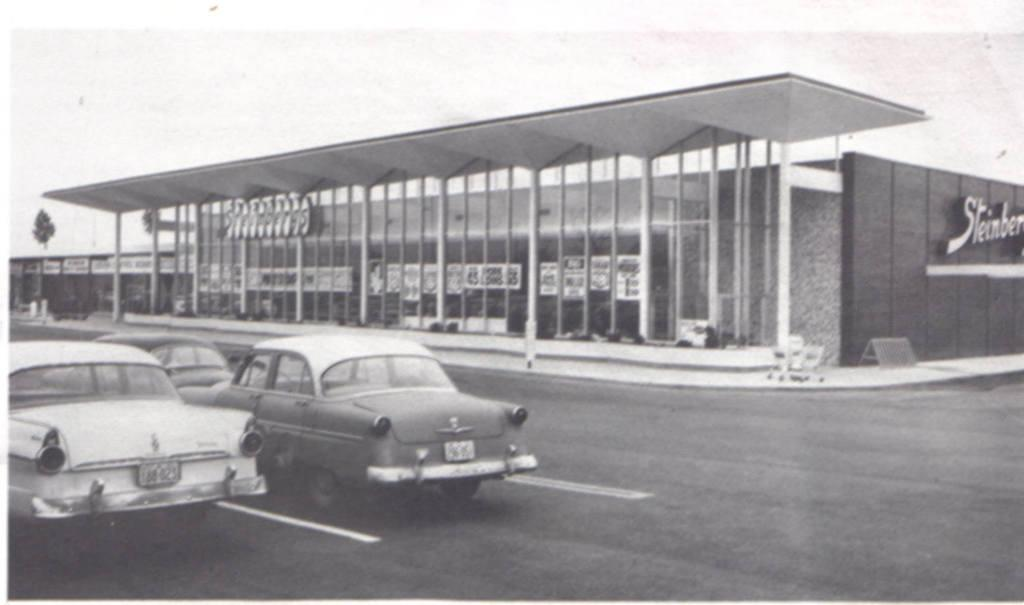What type of picture is in the image? The image contains a black and white picture. What can be seen on the road in the image? There are cars on the road in the image. What type of structure is present in the image? There is a building in the image. What is visible in the background of the image? There is a tree and the sky visible in the background of the image. What type of furniture can be seen in the image? There is no furniture present in the image. How many oranges are visible on the tree in the image? There are no oranges visible in the image, as it does not depict a tree with fruit. 